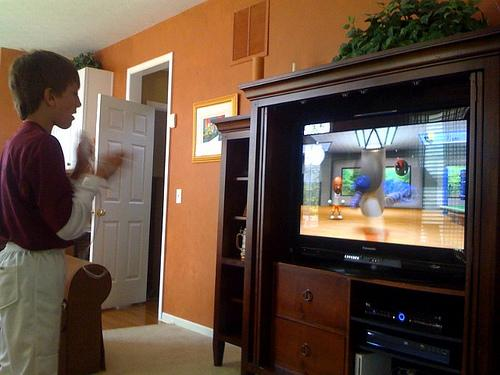What is the person engaged in? Please explain your reasoning. gaming. You can tell by the controllers he is holding and what he was doing as to what the answer is. 